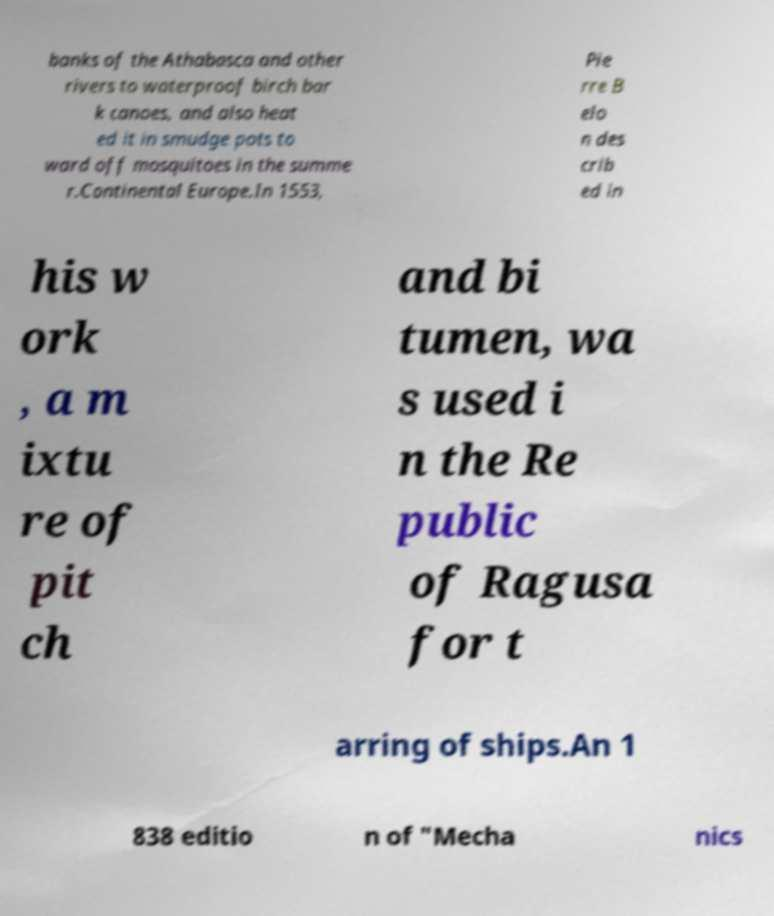Could you assist in decoding the text presented in this image and type it out clearly? banks of the Athabasca and other rivers to waterproof birch bar k canoes, and also heat ed it in smudge pots to ward off mosquitoes in the summe r.Continental Europe.In 1553, Pie rre B elo n des crib ed in his w ork , a m ixtu re of pit ch and bi tumen, wa s used i n the Re public of Ragusa for t arring of ships.An 1 838 editio n of "Mecha nics 